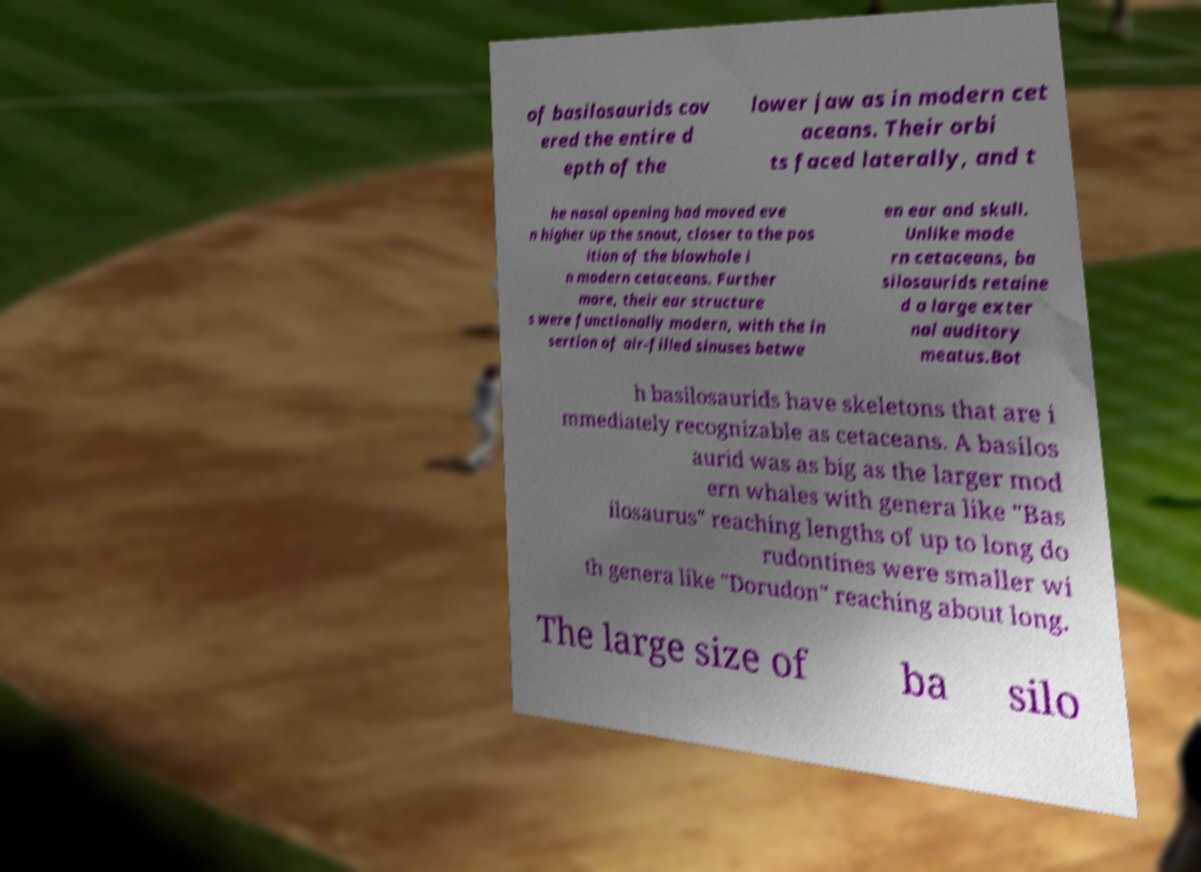Could you assist in decoding the text presented in this image and type it out clearly? of basilosaurids cov ered the entire d epth of the lower jaw as in modern cet aceans. Their orbi ts faced laterally, and t he nasal opening had moved eve n higher up the snout, closer to the pos ition of the blowhole i n modern cetaceans. Further more, their ear structure s were functionally modern, with the in sertion of air-filled sinuses betwe en ear and skull. Unlike mode rn cetaceans, ba silosaurids retaine d a large exter nal auditory meatus.Bot h basilosaurids have skeletons that are i mmediately recognizable as cetaceans. A basilos aurid was as big as the larger mod ern whales with genera like "Bas ilosaurus" reaching lengths of up to long do rudontines were smaller wi th genera like "Dorudon" reaching about long. The large size of ba silo 